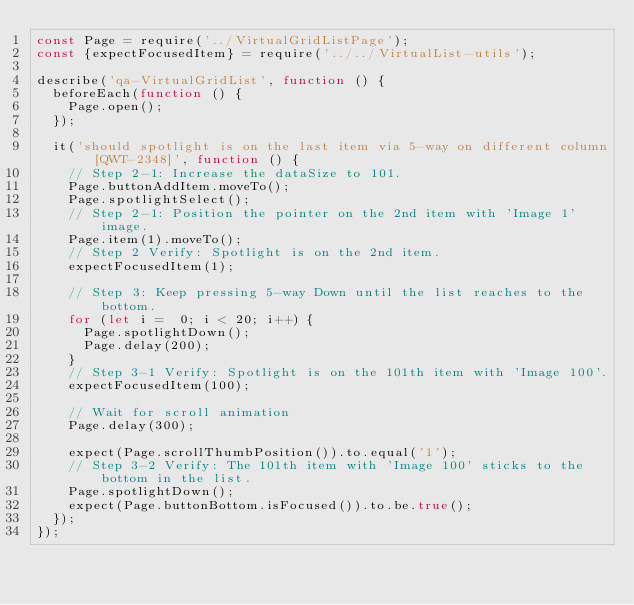Convert code to text. <code><loc_0><loc_0><loc_500><loc_500><_JavaScript_>const Page = require('../VirtualGridListPage');
const {expectFocusedItem} = require('../../VirtualList-utils');

describe('qa-VirtualGridList', function () {
	beforeEach(function () {
		Page.open();
	});

	it('should spotlight is on the last item via 5-way on different column [QWT-2348]', function () {
		// Step 2-1: Increase the dataSize to 101.
		Page.buttonAddItem.moveTo();
		Page.spotlightSelect();
		// Step 2-1: Position the pointer on the 2nd item with 'Image 1' image.
		Page.item(1).moveTo();
		// Step 2 Verify: Spotlight is on the 2nd item.
		expectFocusedItem(1);

		// Step 3: Keep pressing 5-way Down until the list reaches to the bottom.
		for (let i =  0; i < 20; i++) {
			Page.spotlightDown();
			Page.delay(200);
		}
		// Step 3-1 Verify: Spotlight is on the 101th item with 'Image 100'.
		expectFocusedItem(100);

		// Wait for scroll animation
		Page.delay(300);

		expect(Page.scrollThumbPosition()).to.equal('1');
		// Step 3-2 Verify: The 101th item with 'Image 100' sticks to the bottom in the list.
		Page.spotlightDown();
		expect(Page.buttonBottom.isFocused()).to.be.true();
	});
});
</code> 